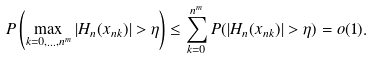Convert formula to latex. <formula><loc_0><loc_0><loc_500><loc_500>P \left ( \max _ { k = 0 , \dots , n ^ { m } } | H _ { n } ( x _ { n k } ) | > \eta \right ) \leq \sum _ { k = 0 } ^ { n ^ { m } } P ( | H _ { n } ( x _ { n k } ) | > \eta ) = o ( 1 ) .</formula> 